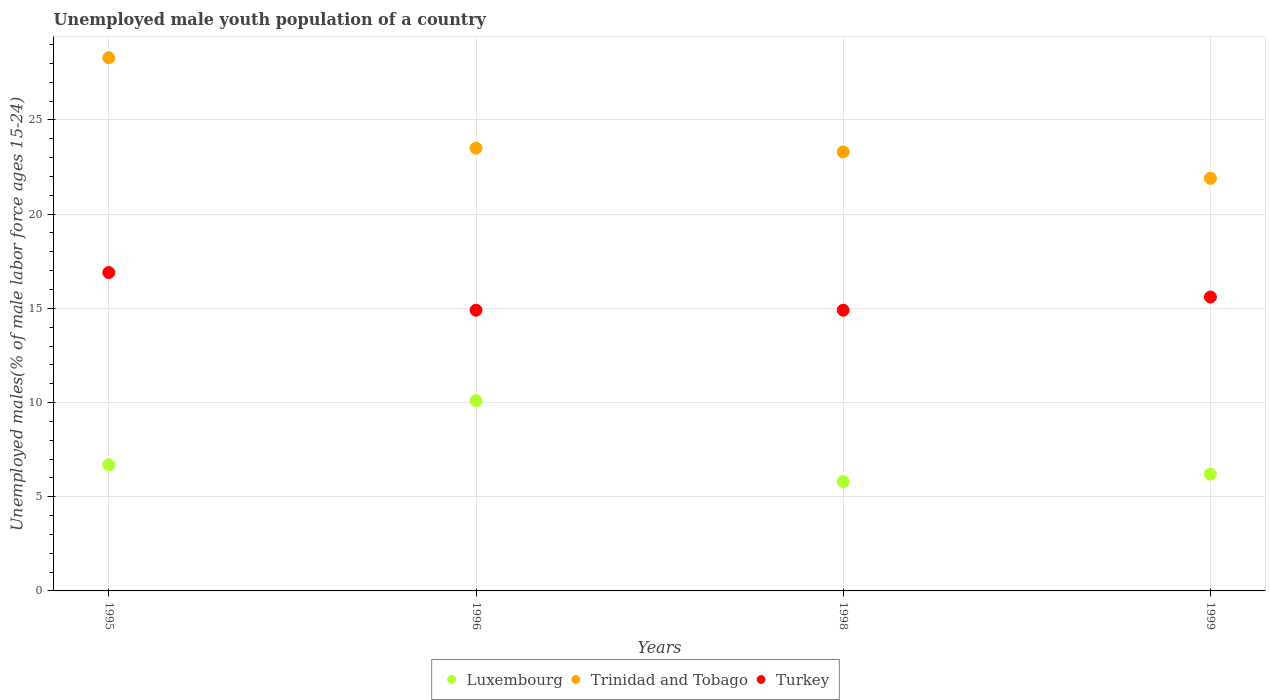How many different coloured dotlines are there?
Provide a short and direct response. 3. What is the percentage of unemployed male youth population in Turkey in 1999?
Keep it short and to the point. 15.6. Across all years, what is the maximum percentage of unemployed male youth population in Turkey?
Your answer should be very brief. 16.9. Across all years, what is the minimum percentage of unemployed male youth population in Trinidad and Tobago?
Provide a short and direct response. 21.9. What is the total percentage of unemployed male youth population in Turkey in the graph?
Ensure brevity in your answer.  62.3. What is the difference between the percentage of unemployed male youth population in Luxembourg in 1995 and that in 1996?
Your response must be concise. -3.4. What is the difference between the percentage of unemployed male youth population in Trinidad and Tobago in 1998 and the percentage of unemployed male youth population in Luxembourg in 1999?
Your answer should be compact. 17.1. What is the average percentage of unemployed male youth population in Turkey per year?
Provide a short and direct response. 15.57. In the year 1995, what is the difference between the percentage of unemployed male youth population in Trinidad and Tobago and percentage of unemployed male youth population in Luxembourg?
Provide a succinct answer. 21.6. What is the ratio of the percentage of unemployed male youth population in Trinidad and Tobago in 1995 to that in 1999?
Your answer should be very brief. 1.29. Is the percentage of unemployed male youth population in Luxembourg in 1995 less than that in 1998?
Keep it short and to the point. No. Is the difference between the percentage of unemployed male youth population in Trinidad and Tobago in 1995 and 1998 greater than the difference between the percentage of unemployed male youth population in Luxembourg in 1995 and 1998?
Your response must be concise. Yes. What is the difference between the highest and the second highest percentage of unemployed male youth population in Trinidad and Tobago?
Offer a very short reply. 4.8. What is the difference between the highest and the lowest percentage of unemployed male youth population in Luxembourg?
Ensure brevity in your answer.  4.3. Is the sum of the percentage of unemployed male youth population in Turkey in 1998 and 1999 greater than the maximum percentage of unemployed male youth population in Luxembourg across all years?
Your answer should be very brief. Yes. Is the percentage of unemployed male youth population in Turkey strictly greater than the percentage of unemployed male youth population in Luxembourg over the years?
Offer a terse response. Yes. Is the percentage of unemployed male youth population in Trinidad and Tobago strictly less than the percentage of unemployed male youth population in Turkey over the years?
Provide a short and direct response. No. How many dotlines are there?
Your answer should be very brief. 3. What is the difference between two consecutive major ticks on the Y-axis?
Provide a short and direct response. 5. Are the values on the major ticks of Y-axis written in scientific E-notation?
Provide a short and direct response. No. Does the graph contain any zero values?
Make the answer very short. No. Does the graph contain grids?
Your answer should be compact. Yes. Where does the legend appear in the graph?
Provide a succinct answer. Bottom center. How are the legend labels stacked?
Provide a succinct answer. Horizontal. What is the title of the graph?
Keep it short and to the point. Unemployed male youth population of a country. Does "Egypt, Arab Rep." appear as one of the legend labels in the graph?
Offer a very short reply. No. What is the label or title of the X-axis?
Offer a very short reply. Years. What is the label or title of the Y-axis?
Ensure brevity in your answer.  Unemployed males(% of male labor force ages 15-24). What is the Unemployed males(% of male labor force ages 15-24) of Luxembourg in 1995?
Your response must be concise. 6.7. What is the Unemployed males(% of male labor force ages 15-24) in Trinidad and Tobago in 1995?
Your response must be concise. 28.3. What is the Unemployed males(% of male labor force ages 15-24) in Turkey in 1995?
Make the answer very short. 16.9. What is the Unemployed males(% of male labor force ages 15-24) in Luxembourg in 1996?
Ensure brevity in your answer.  10.1. What is the Unemployed males(% of male labor force ages 15-24) in Turkey in 1996?
Your answer should be very brief. 14.9. What is the Unemployed males(% of male labor force ages 15-24) in Luxembourg in 1998?
Provide a short and direct response. 5.8. What is the Unemployed males(% of male labor force ages 15-24) in Trinidad and Tobago in 1998?
Offer a terse response. 23.3. What is the Unemployed males(% of male labor force ages 15-24) of Turkey in 1998?
Provide a short and direct response. 14.9. What is the Unemployed males(% of male labor force ages 15-24) of Luxembourg in 1999?
Give a very brief answer. 6.2. What is the Unemployed males(% of male labor force ages 15-24) in Trinidad and Tobago in 1999?
Keep it short and to the point. 21.9. What is the Unemployed males(% of male labor force ages 15-24) of Turkey in 1999?
Provide a short and direct response. 15.6. Across all years, what is the maximum Unemployed males(% of male labor force ages 15-24) in Luxembourg?
Provide a short and direct response. 10.1. Across all years, what is the maximum Unemployed males(% of male labor force ages 15-24) of Trinidad and Tobago?
Offer a terse response. 28.3. Across all years, what is the maximum Unemployed males(% of male labor force ages 15-24) in Turkey?
Your answer should be compact. 16.9. Across all years, what is the minimum Unemployed males(% of male labor force ages 15-24) in Luxembourg?
Offer a very short reply. 5.8. Across all years, what is the minimum Unemployed males(% of male labor force ages 15-24) in Trinidad and Tobago?
Keep it short and to the point. 21.9. Across all years, what is the minimum Unemployed males(% of male labor force ages 15-24) in Turkey?
Offer a very short reply. 14.9. What is the total Unemployed males(% of male labor force ages 15-24) in Luxembourg in the graph?
Your answer should be very brief. 28.8. What is the total Unemployed males(% of male labor force ages 15-24) of Trinidad and Tobago in the graph?
Your answer should be compact. 97. What is the total Unemployed males(% of male labor force ages 15-24) of Turkey in the graph?
Ensure brevity in your answer.  62.3. What is the difference between the Unemployed males(% of male labor force ages 15-24) in Luxembourg in 1995 and that in 1996?
Offer a terse response. -3.4. What is the difference between the Unemployed males(% of male labor force ages 15-24) in Trinidad and Tobago in 1995 and that in 1996?
Provide a succinct answer. 4.8. What is the difference between the Unemployed males(% of male labor force ages 15-24) in Trinidad and Tobago in 1995 and that in 1998?
Your response must be concise. 5. What is the difference between the Unemployed males(% of male labor force ages 15-24) of Turkey in 1995 and that in 1999?
Your answer should be compact. 1.3. What is the difference between the Unemployed males(% of male labor force ages 15-24) in Turkey in 1996 and that in 1998?
Keep it short and to the point. 0. What is the difference between the Unemployed males(% of male labor force ages 15-24) of Luxembourg in 1996 and that in 1999?
Your answer should be very brief. 3.9. What is the difference between the Unemployed males(% of male labor force ages 15-24) in Turkey in 1996 and that in 1999?
Your response must be concise. -0.7. What is the difference between the Unemployed males(% of male labor force ages 15-24) of Turkey in 1998 and that in 1999?
Provide a short and direct response. -0.7. What is the difference between the Unemployed males(% of male labor force ages 15-24) in Luxembourg in 1995 and the Unemployed males(% of male labor force ages 15-24) in Trinidad and Tobago in 1996?
Your answer should be very brief. -16.8. What is the difference between the Unemployed males(% of male labor force ages 15-24) of Luxembourg in 1995 and the Unemployed males(% of male labor force ages 15-24) of Trinidad and Tobago in 1998?
Make the answer very short. -16.6. What is the difference between the Unemployed males(% of male labor force ages 15-24) of Luxembourg in 1995 and the Unemployed males(% of male labor force ages 15-24) of Trinidad and Tobago in 1999?
Offer a very short reply. -15.2. What is the difference between the Unemployed males(% of male labor force ages 15-24) of Luxembourg in 1996 and the Unemployed males(% of male labor force ages 15-24) of Trinidad and Tobago in 1999?
Provide a short and direct response. -11.8. What is the difference between the Unemployed males(% of male labor force ages 15-24) of Luxembourg in 1996 and the Unemployed males(% of male labor force ages 15-24) of Turkey in 1999?
Provide a succinct answer. -5.5. What is the difference between the Unemployed males(% of male labor force ages 15-24) in Luxembourg in 1998 and the Unemployed males(% of male labor force ages 15-24) in Trinidad and Tobago in 1999?
Your answer should be very brief. -16.1. What is the difference between the Unemployed males(% of male labor force ages 15-24) of Luxembourg in 1998 and the Unemployed males(% of male labor force ages 15-24) of Turkey in 1999?
Keep it short and to the point. -9.8. What is the average Unemployed males(% of male labor force ages 15-24) in Luxembourg per year?
Your answer should be compact. 7.2. What is the average Unemployed males(% of male labor force ages 15-24) of Trinidad and Tobago per year?
Your answer should be compact. 24.25. What is the average Unemployed males(% of male labor force ages 15-24) in Turkey per year?
Ensure brevity in your answer.  15.57. In the year 1995, what is the difference between the Unemployed males(% of male labor force ages 15-24) of Luxembourg and Unemployed males(% of male labor force ages 15-24) of Trinidad and Tobago?
Give a very brief answer. -21.6. In the year 1995, what is the difference between the Unemployed males(% of male labor force ages 15-24) in Trinidad and Tobago and Unemployed males(% of male labor force ages 15-24) in Turkey?
Make the answer very short. 11.4. In the year 1996, what is the difference between the Unemployed males(% of male labor force ages 15-24) in Luxembourg and Unemployed males(% of male labor force ages 15-24) in Turkey?
Ensure brevity in your answer.  -4.8. In the year 1996, what is the difference between the Unemployed males(% of male labor force ages 15-24) of Trinidad and Tobago and Unemployed males(% of male labor force ages 15-24) of Turkey?
Offer a very short reply. 8.6. In the year 1998, what is the difference between the Unemployed males(% of male labor force ages 15-24) in Luxembourg and Unemployed males(% of male labor force ages 15-24) in Trinidad and Tobago?
Ensure brevity in your answer.  -17.5. In the year 1998, what is the difference between the Unemployed males(% of male labor force ages 15-24) of Luxembourg and Unemployed males(% of male labor force ages 15-24) of Turkey?
Give a very brief answer. -9.1. In the year 1999, what is the difference between the Unemployed males(% of male labor force ages 15-24) in Luxembourg and Unemployed males(% of male labor force ages 15-24) in Trinidad and Tobago?
Your answer should be compact. -15.7. What is the ratio of the Unemployed males(% of male labor force ages 15-24) in Luxembourg in 1995 to that in 1996?
Offer a very short reply. 0.66. What is the ratio of the Unemployed males(% of male labor force ages 15-24) of Trinidad and Tobago in 1995 to that in 1996?
Make the answer very short. 1.2. What is the ratio of the Unemployed males(% of male labor force ages 15-24) of Turkey in 1995 to that in 1996?
Provide a succinct answer. 1.13. What is the ratio of the Unemployed males(% of male labor force ages 15-24) in Luxembourg in 1995 to that in 1998?
Your response must be concise. 1.16. What is the ratio of the Unemployed males(% of male labor force ages 15-24) of Trinidad and Tobago in 1995 to that in 1998?
Make the answer very short. 1.21. What is the ratio of the Unemployed males(% of male labor force ages 15-24) in Turkey in 1995 to that in 1998?
Your answer should be compact. 1.13. What is the ratio of the Unemployed males(% of male labor force ages 15-24) in Luxembourg in 1995 to that in 1999?
Offer a very short reply. 1.08. What is the ratio of the Unemployed males(% of male labor force ages 15-24) in Trinidad and Tobago in 1995 to that in 1999?
Your response must be concise. 1.29. What is the ratio of the Unemployed males(% of male labor force ages 15-24) in Luxembourg in 1996 to that in 1998?
Ensure brevity in your answer.  1.74. What is the ratio of the Unemployed males(% of male labor force ages 15-24) in Trinidad and Tobago in 1996 to that in 1998?
Provide a succinct answer. 1.01. What is the ratio of the Unemployed males(% of male labor force ages 15-24) of Turkey in 1996 to that in 1998?
Give a very brief answer. 1. What is the ratio of the Unemployed males(% of male labor force ages 15-24) in Luxembourg in 1996 to that in 1999?
Keep it short and to the point. 1.63. What is the ratio of the Unemployed males(% of male labor force ages 15-24) of Trinidad and Tobago in 1996 to that in 1999?
Provide a short and direct response. 1.07. What is the ratio of the Unemployed males(% of male labor force ages 15-24) in Turkey in 1996 to that in 1999?
Provide a short and direct response. 0.96. What is the ratio of the Unemployed males(% of male labor force ages 15-24) in Luxembourg in 1998 to that in 1999?
Offer a very short reply. 0.94. What is the ratio of the Unemployed males(% of male labor force ages 15-24) in Trinidad and Tobago in 1998 to that in 1999?
Offer a very short reply. 1.06. What is the ratio of the Unemployed males(% of male labor force ages 15-24) of Turkey in 1998 to that in 1999?
Your response must be concise. 0.96. What is the difference between the highest and the second highest Unemployed males(% of male labor force ages 15-24) in Luxembourg?
Offer a terse response. 3.4. What is the difference between the highest and the second highest Unemployed males(% of male labor force ages 15-24) in Trinidad and Tobago?
Offer a terse response. 4.8. What is the difference between the highest and the second highest Unemployed males(% of male labor force ages 15-24) of Turkey?
Give a very brief answer. 1.3. What is the difference between the highest and the lowest Unemployed males(% of male labor force ages 15-24) of Luxembourg?
Ensure brevity in your answer.  4.3. What is the difference between the highest and the lowest Unemployed males(% of male labor force ages 15-24) of Turkey?
Your answer should be very brief. 2. 